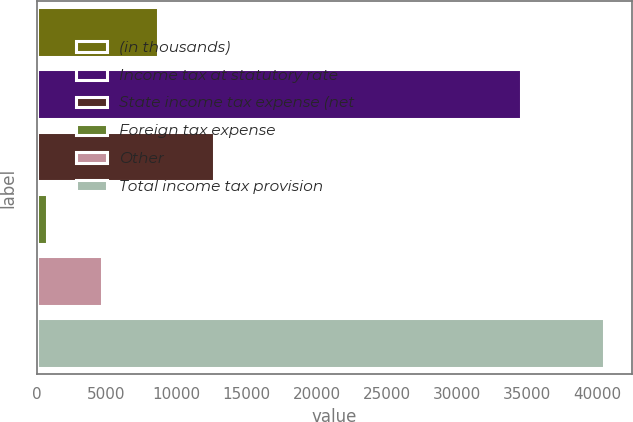<chart> <loc_0><loc_0><loc_500><loc_500><bar_chart><fcel>(in thousands)<fcel>Income tax at statutory rate<fcel>State income tax expense (net<fcel>Foreign tax expense<fcel>Other<fcel>Total income tax provision<nl><fcel>8671.4<fcel>34548<fcel>12644.1<fcel>726<fcel>4698.7<fcel>40453<nl></chart> 